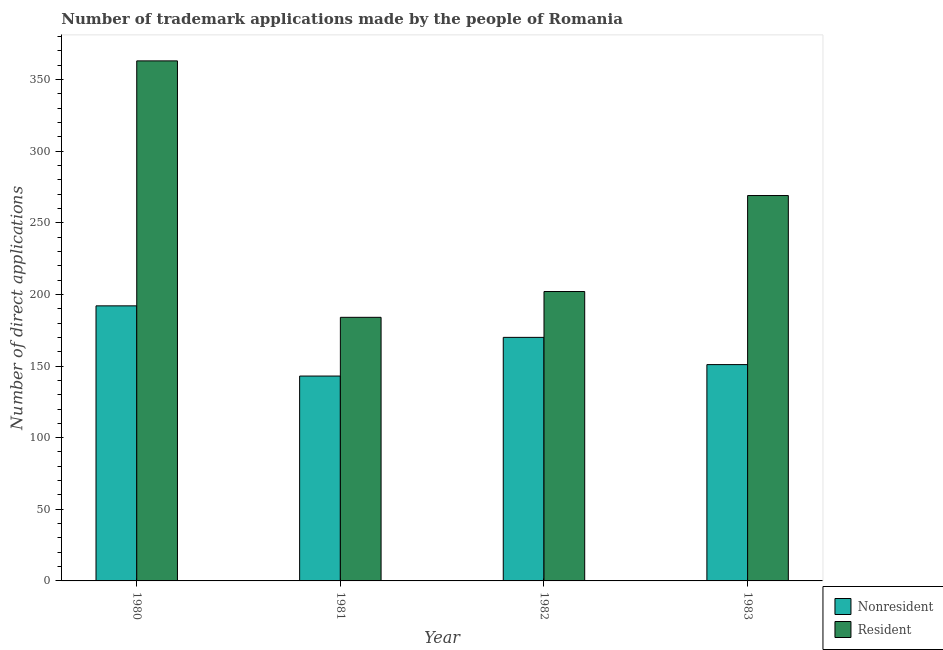Are the number of bars per tick equal to the number of legend labels?
Provide a succinct answer. Yes. Are the number of bars on each tick of the X-axis equal?
Offer a terse response. Yes. How many bars are there on the 2nd tick from the right?
Offer a very short reply. 2. What is the label of the 1st group of bars from the left?
Provide a succinct answer. 1980. In how many cases, is the number of bars for a given year not equal to the number of legend labels?
Your response must be concise. 0. What is the number of trademark applications made by non residents in 1980?
Give a very brief answer. 192. Across all years, what is the maximum number of trademark applications made by residents?
Offer a terse response. 363. Across all years, what is the minimum number of trademark applications made by non residents?
Provide a succinct answer. 143. In which year was the number of trademark applications made by non residents maximum?
Your answer should be very brief. 1980. What is the total number of trademark applications made by non residents in the graph?
Offer a very short reply. 656. What is the difference between the number of trademark applications made by non residents in 1981 and that in 1982?
Make the answer very short. -27. What is the difference between the number of trademark applications made by non residents in 1982 and the number of trademark applications made by residents in 1980?
Ensure brevity in your answer.  -22. What is the average number of trademark applications made by residents per year?
Provide a short and direct response. 254.5. In how many years, is the number of trademark applications made by residents greater than 190?
Make the answer very short. 3. What is the ratio of the number of trademark applications made by non residents in 1980 to that in 1982?
Your answer should be very brief. 1.13. What is the difference between the highest and the second highest number of trademark applications made by non residents?
Make the answer very short. 22. What is the difference between the highest and the lowest number of trademark applications made by residents?
Provide a short and direct response. 179. In how many years, is the number of trademark applications made by residents greater than the average number of trademark applications made by residents taken over all years?
Provide a short and direct response. 2. What does the 2nd bar from the left in 1981 represents?
Provide a succinct answer. Resident. What does the 2nd bar from the right in 1981 represents?
Provide a succinct answer. Nonresident. How many bars are there?
Offer a very short reply. 8. Are all the bars in the graph horizontal?
Your response must be concise. No. How many years are there in the graph?
Your response must be concise. 4. What is the difference between two consecutive major ticks on the Y-axis?
Offer a very short reply. 50. Are the values on the major ticks of Y-axis written in scientific E-notation?
Your answer should be compact. No. Does the graph contain any zero values?
Offer a terse response. No. Does the graph contain grids?
Your answer should be very brief. No. How many legend labels are there?
Keep it short and to the point. 2. What is the title of the graph?
Provide a short and direct response. Number of trademark applications made by the people of Romania. What is the label or title of the X-axis?
Provide a succinct answer. Year. What is the label or title of the Y-axis?
Your answer should be very brief. Number of direct applications. What is the Number of direct applications in Nonresident in 1980?
Provide a succinct answer. 192. What is the Number of direct applications in Resident in 1980?
Provide a succinct answer. 363. What is the Number of direct applications in Nonresident in 1981?
Provide a short and direct response. 143. What is the Number of direct applications of Resident in 1981?
Provide a short and direct response. 184. What is the Number of direct applications in Nonresident in 1982?
Provide a short and direct response. 170. What is the Number of direct applications in Resident in 1982?
Keep it short and to the point. 202. What is the Number of direct applications in Nonresident in 1983?
Keep it short and to the point. 151. What is the Number of direct applications in Resident in 1983?
Provide a succinct answer. 269. Across all years, what is the maximum Number of direct applications in Nonresident?
Keep it short and to the point. 192. Across all years, what is the maximum Number of direct applications of Resident?
Ensure brevity in your answer.  363. Across all years, what is the minimum Number of direct applications of Nonresident?
Make the answer very short. 143. Across all years, what is the minimum Number of direct applications in Resident?
Give a very brief answer. 184. What is the total Number of direct applications in Nonresident in the graph?
Ensure brevity in your answer.  656. What is the total Number of direct applications of Resident in the graph?
Your answer should be compact. 1018. What is the difference between the Number of direct applications of Resident in 1980 and that in 1981?
Make the answer very short. 179. What is the difference between the Number of direct applications in Resident in 1980 and that in 1982?
Ensure brevity in your answer.  161. What is the difference between the Number of direct applications in Nonresident in 1980 and that in 1983?
Ensure brevity in your answer.  41. What is the difference between the Number of direct applications of Resident in 1980 and that in 1983?
Ensure brevity in your answer.  94. What is the difference between the Number of direct applications in Nonresident in 1981 and that in 1982?
Your answer should be compact. -27. What is the difference between the Number of direct applications of Resident in 1981 and that in 1982?
Offer a very short reply. -18. What is the difference between the Number of direct applications of Nonresident in 1981 and that in 1983?
Provide a short and direct response. -8. What is the difference between the Number of direct applications in Resident in 1981 and that in 1983?
Offer a terse response. -85. What is the difference between the Number of direct applications in Nonresident in 1982 and that in 1983?
Provide a succinct answer. 19. What is the difference between the Number of direct applications in Resident in 1982 and that in 1983?
Offer a very short reply. -67. What is the difference between the Number of direct applications of Nonresident in 1980 and the Number of direct applications of Resident in 1981?
Provide a succinct answer. 8. What is the difference between the Number of direct applications of Nonresident in 1980 and the Number of direct applications of Resident in 1983?
Provide a succinct answer. -77. What is the difference between the Number of direct applications in Nonresident in 1981 and the Number of direct applications in Resident in 1982?
Make the answer very short. -59. What is the difference between the Number of direct applications in Nonresident in 1981 and the Number of direct applications in Resident in 1983?
Offer a terse response. -126. What is the difference between the Number of direct applications of Nonresident in 1982 and the Number of direct applications of Resident in 1983?
Keep it short and to the point. -99. What is the average Number of direct applications of Nonresident per year?
Provide a short and direct response. 164. What is the average Number of direct applications of Resident per year?
Provide a short and direct response. 254.5. In the year 1980, what is the difference between the Number of direct applications in Nonresident and Number of direct applications in Resident?
Ensure brevity in your answer.  -171. In the year 1981, what is the difference between the Number of direct applications in Nonresident and Number of direct applications in Resident?
Your answer should be compact. -41. In the year 1982, what is the difference between the Number of direct applications of Nonresident and Number of direct applications of Resident?
Make the answer very short. -32. In the year 1983, what is the difference between the Number of direct applications in Nonresident and Number of direct applications in Resident?
Offer a terse response. -118. What is the ratio of the Number of direct applications of Nonresident in 1980 to that in 1981?
Provide a succinct answer. 1.34. What is the ratio of the Number of direct applications of Resident in 1980 to that in 1981?
Offer a terse response. 1.97. What is the ratio of the Number of direct applications of Nonresident in 1980 to that in 1982?
Ensure brevity in your answer.  1.13. What is the ratio of the Number of direct applications of Resident in 1980 to that in 1982?
Offer a very short reply. 1.8. What is the ratio of the Number of direct applications in Nonresident in 1980 to that in 1983?
Ensure brevity in your answer.  1.27. What is the ratio of the Number of direct applications of Resident in 1980 to that in 1983?
Your response must be concise. 1.35. What is the ratio of the Number of direct applications of Nonresident in 1981 to that in 1982?
Your response must be concise. 0.84. What is the ratio of the Number of direct applications in Resident in 1981 to that in 1982?
Make the answer very short. 0.91. What is the ratio of the Number of direct applications in Nonresident in 1981 to that in 1983?
Offer a terse response. 0.95. What is the ratio of the Number of direct applications in Resident in 1981 to that in 1983?
Provide a succinct answer. 0.68. What is the ratio of the Number of direct applications of Nonresident in 1982 to that in 1983?
Your response must be concise. 1.13. What is the ratio of the Number of direct applications in Resident in 1982 to that in 1983?
Keep it short and to the point. 0.75. What is the difference between the highest and the second highest Number of direct applications of Resident?
Offer a very short reply. 94. What is the difference between the highest and the lowest Number of direct applications of Nonresident?
Ensure brevity in your answer.  49. What is the difference between the highest and the lowest Number of direct applications in Resident?
Provide a succinct answer. 179. 